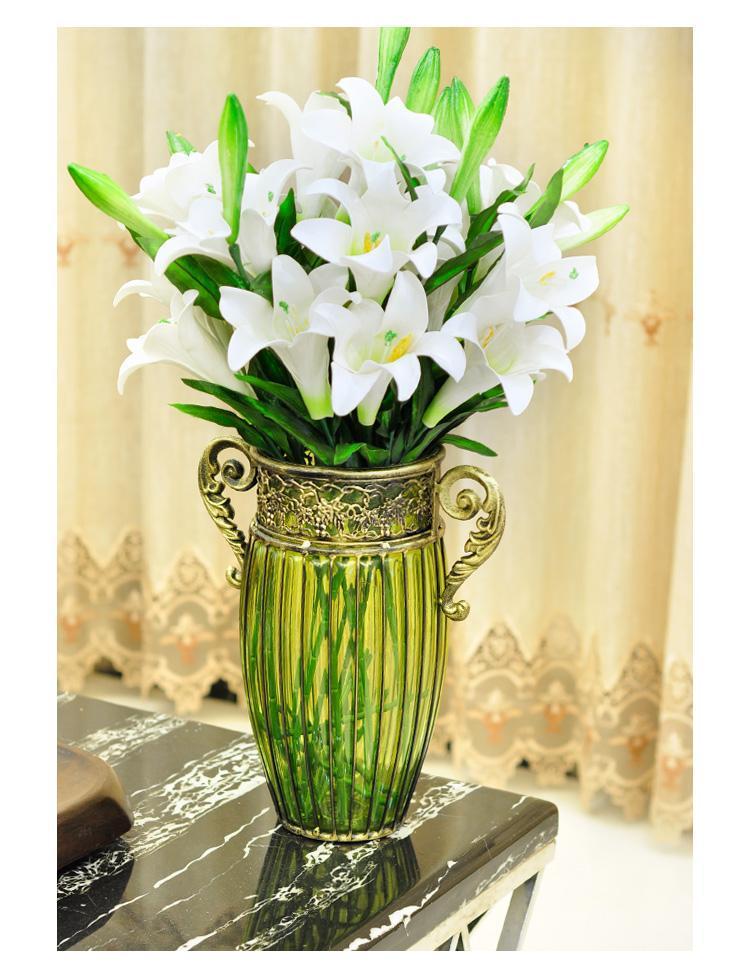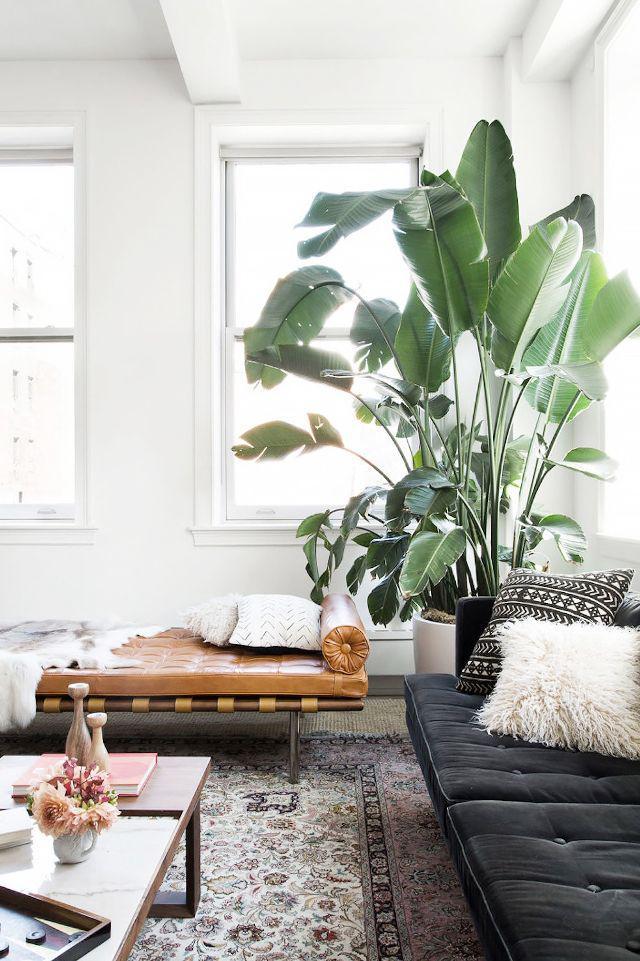The first image is the image on the left, the second image is the image on the right. Assess this claim about the two images: "Curtains are visible in the background of the image on the left.". Correct or not? Answer yes or no. Yes. 